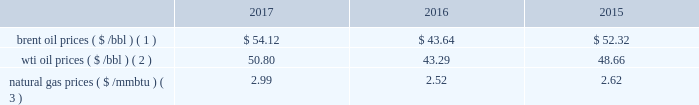Bhge 2017 form 10-k | 27 the short term .
We do , however , view the long term economics of the lng industry as positive given our outlook for supply and demand .
2022 refinery , petrochemical and industrial projects : in refining , we believe large , complex refineries should gain advantage in a more competitive , oversupplied landscape in 2018 as the industry globalizes and refiners position to meet local demand and secure export potential .
In petrochemicals , we continue to see healthy demand and cost-advantaged supply driving projects forward in 2018 .
The industrial market continues to grow as outdated infrastructure is replaced , policy changes come into effect and power is decentralized .
We continue to see growing demand across these markets in 2018 .
We have other segments in our portfolio that are more correlated with different industrial metrics such as our digital solutions business .
Overall , we believe our portfolio is uniquely positioned to compete across the value chain , and deliver unique solutions for our customers .
We remain optimistic about the long-term economics of the industry , but are continuing to operate with flexibility given our expectations for volatility and changing assumptions in the near term .
In 2016 , solar and wind net additions exceeded coal and gas for the first time and it continued throughout 2017 .
Governments may change or may not continue incentives for renewable energy additions .
In the long term , renewables' cost decline may accelerate to compete with new-built fossil capacity , however , we do not anticipate any significant impacts to our business in the foreseeable future .
Despite the near-term volatility , the long-term outlook for our industry remains strong .
We believe the world 2019s demand for energy will continue to rise , and the supply of energy will continue to increase in complexity , requiring greater service intensity and more advanced technology from oilfield service companies .
As such , we remain focused on delivering innovative cost-efficient solutions that deliver step changes in operating and economic performance for our customers .
Business environment the following discussion and analysis summarizes the significant factors affecting our results of operations , financial condition and liquidity position as of and for the year ended december 31 , 2017 , 2016 and 2015 , and should be read in conjunction with the consolidated and combined financial statements and related notes of the company .
Amounts reported in millions in graphs within this report are computed based on the amounts in hundreds .
As a result , the sum of the components reported in millions may not equal the total amount reported in millions due to rounding .
We operate in more than 120 countries helping customers find , evaluate , drill , produce , transport and process hydrocarbon resources .
Our revenue is predominately generated from the sale of products and services to major , national , and independent oil and natural gas companies worldwide , and is dependent on spending by our customers for oil and natural gas exploration , field development and production .
This spending is driven by a number of factors , including our customers' forecasts of future energy demand and supply , their access to resources to develop and produce oil and natural gas , their ability to fund their capital programs , the impact of new government regulations and most importantly , their expectations for oil and natural gas prices as a key driver of their cash flows .
Oil and natural gas prices oil and natural gas prices are summarized in the table below as averages of the daily closing prices during each of the periods indicated. .
Brent oil prices ( $ /bbl ) ( 1 ) $ 54.12 $ 43.64 $ 52.32 wti oil prices ( $ /bbl ) ( 2 ) 50.80 43.29 48.66 natural gas prices ( $ /mmbtu ) ( 3 ) 2.99 2.52 2.62 ( 1 ) energy information administration ( eia ) europe brent spot price per barrel .
What is the growth rate in brent oil prices from 2016 to 2017? 
Computations: ((54.12 - 43.64) / 43.64)
Answer: 0.24015. 